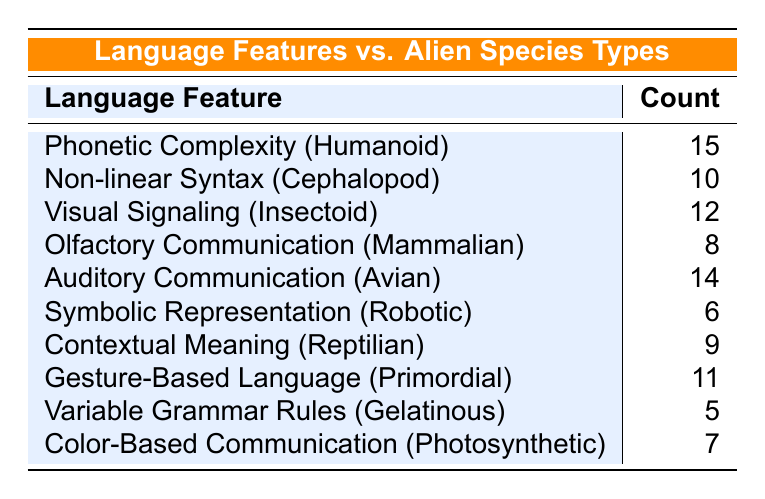What is the count of Phonetic Complexity for Humanoid species? The table indicates the specific count for each language feature and species type. The row for Phonetic Complexity associated with Humanoid explicitly shows a count of 15.
Answer: 15 How many language features have a count greater than 10? To determine this, I will look through the counts provided for each language feature. The features with counts greater than 10 are Phonetic Complexity (15), Non-linear Syntax (10), Visual Signaling (12), Auditory Communication (14), and Gesture-Based Language (11), totaling 5 features.
Answer: 5 Is there any species type that uses Symbolic Representation? The table lists Symbolic Representation under Robotic as a species type. Thus, it can be confirmed that yes, there is a species type that uses this language feature.
Answer: Yes What is the difference in count between Auditory Communication and Olfactory Communication? To find this difference, subtract the count of Olfactory Communication (8) from the count of Auditory Communication (14), resulting in 14 - 8 = 6.
Answer: 6 What is the average count of language features for all species types? To calculate the average, first, sum all the counts: 15 + 10 + 12 + 8 + 14 + 6 + 9 + 11 + 5 + 7 = 87. There are 10 language features, so I divide the total count by the number of features: 87 / 10 = 8.7.
Answer: 8.7 Which species type has the lowest language feature count, and what is the count? Reviewing the table, Variable Grammar Rules under Gelatinous has the lowest count at 5, which is the minimum across all species types and language features.
Answer: Gelatinous, 5 What percentage of the total counts does the count for Visual Signaling represent? First, find total counts: 87. Then for Visual Signaling, the count is 12. Calculate the percentage as (12 / 87) * 100, which approximates to 13.79%.
Answer: Approximately 13.79% Which species types use language features related to visual and auditory communication? Referring to the table, Auditory Communication is associated with Avian (count of 14) and Visual Signaling with Insectoid (count of 12). Both features correspond to distinct species types, as listed.
Answer: Avian (Auditory), Insectoid (Visual) 